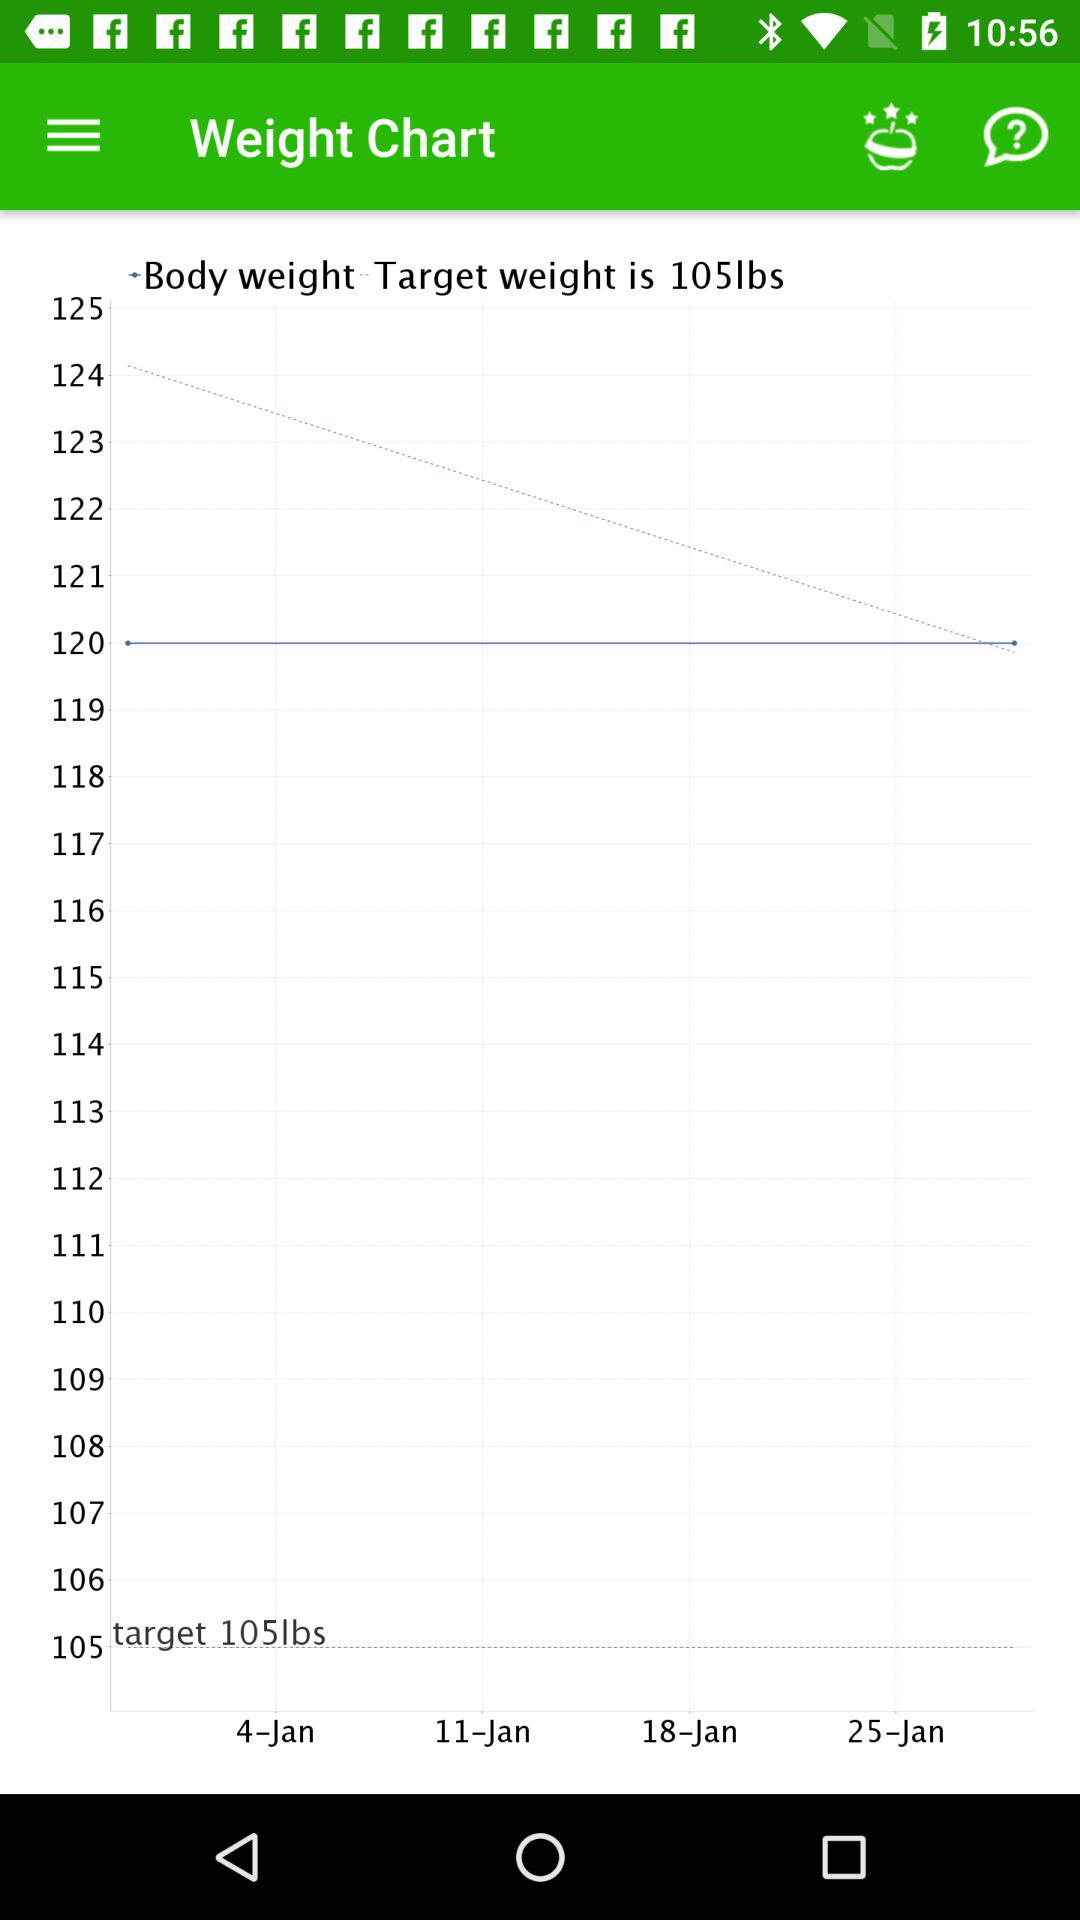Upto what date Weight record can be present?
When the provided information is insufficient, respond with <no answer>. <no answer> 